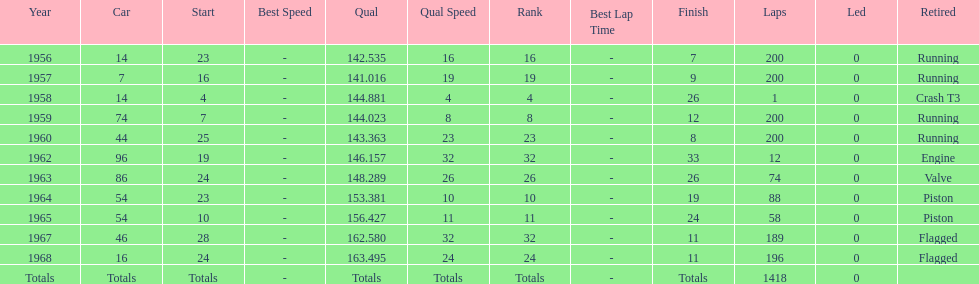Tell me the number of times he finished above 10th place. 3. 